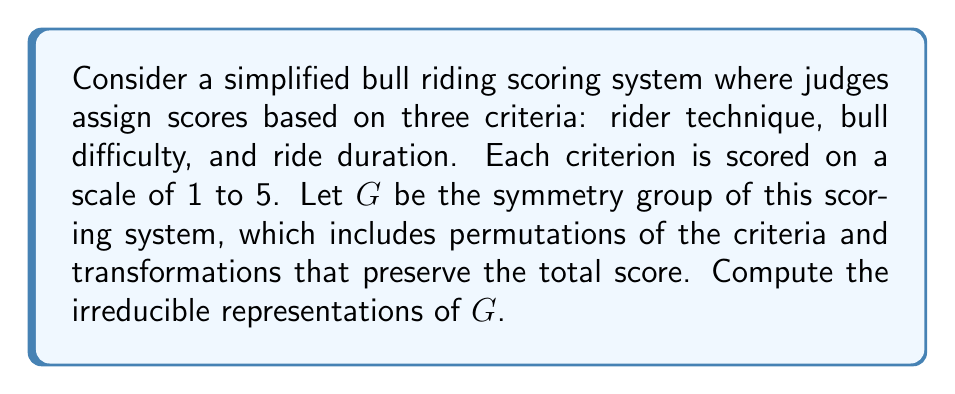Can you answer this question? 1) First, we need to identify the group $G$. The group consists of permutations of the three criteria and score-preserving transformations. The permutations form a subgroup isomorphic to $S_3$, the symmetric group on 3 elements.

2) The score-preserving transformations form a cyclic group of order 5, as adding or subtracting 5 from the total score returns to the same state. Let's call this group $C_5$.

3) The full group $G$ is thus isomorphic to the direct product $S_3 \times C_5$.

4) To find the irreducible representations of $G$, we can use the fact that the irreducible representations of a direct product are tensor products of the irreducible representations of its factors.

5) For $S_3$:
   - It has three irreducible representations: the trivial representation (1-dimensional), the sign representation (1-dimensional), and the standard representation (2-dimensional).

6) For $C_5$:
   - It has five 1-dimensional irreducible representations, given by $\chi_k(g) = e^{2\pi i k g / 5}$ for $k = 0, 1, 2, 3, 4$.

7) The irreducible representations of $G$ are thus:
   - $1 \otimes \chi_k$ for $k = 0, 1, 2, 3, 4$ (five 1-dimensional representations)
   - $\text{sign} \otimes \chi_k$ for $k = 0, 1, 2, 3, 4$ (five 1-dimensional representations)
   - $\text{standard} \otimes \chi_k$ for $k = 0, 1, 2, 3, 4$ (five 2-dimensional representations)

8) In total, we have 10 1-dimensional irreducible representations and 5 2-dimensional irreducible representations.
Answer: $10$ 1-dimensional and $5$ 2-dimensional irreducible representations 